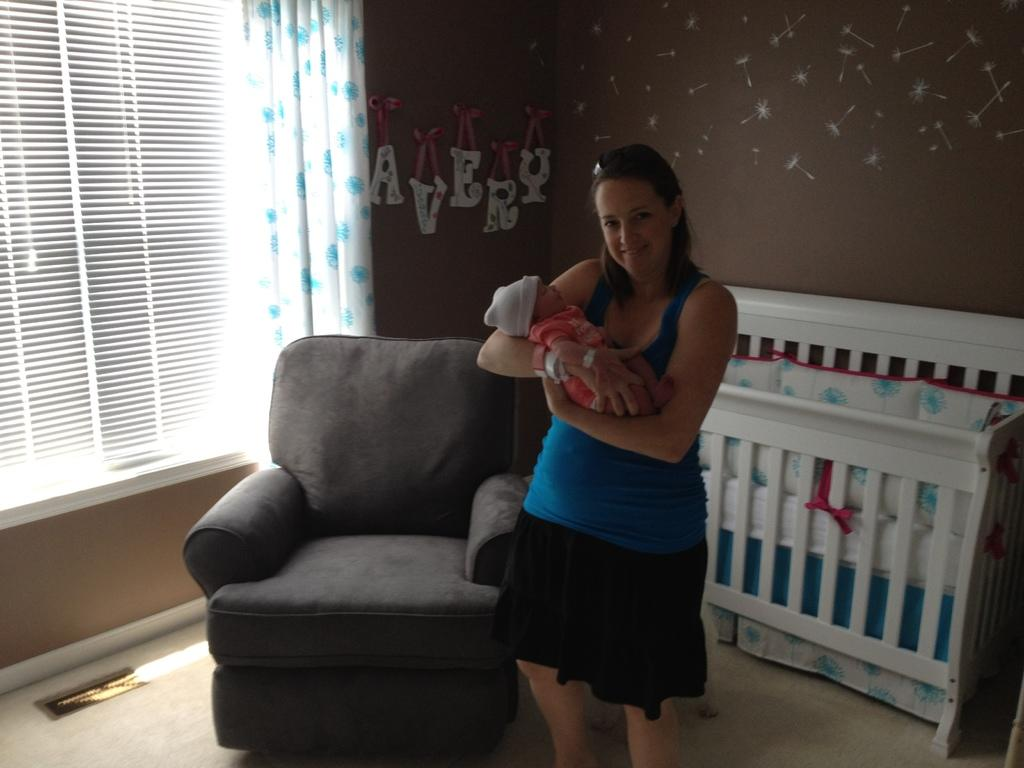Who is present in the image? There is a woman in the image. What is the woman holding? The woman is holding a baby. What type of furniture is in the image? There is a sofa in the image. What is used for the baby's sleep in the image? There is a cradle in the image. What can be seen in the background of the image? There are curtains and window blinds in the background of the image. What type of pan is being used to sail in the image? There is no pan or sailing activity present in the image. 